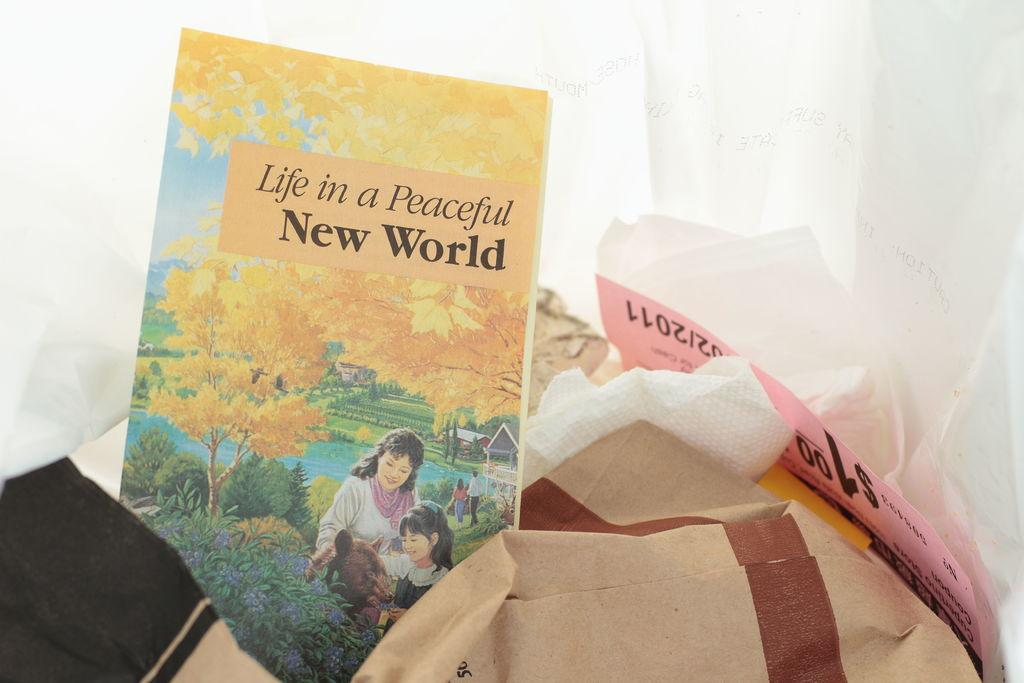Provide a one-sentence caption for the provided image. In what appears to be a trash bag lies a lonely copy of the book "Life in a Peaceful New World.". 